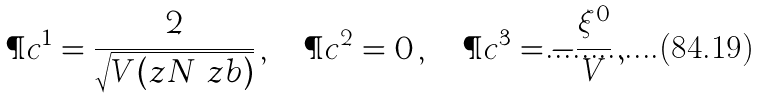Convert formula to latex. <formula><loc_0><loc_0><loc_500><loc_500>\P c ^ { 1 } = \frac { 2 } { \sqrt { V ( z N \ z b ) } } \, , \quad \P c ^ { 2 } = 0 \, , \quad \P c ^ { 3 } = - \frac { \xi ^ { 0 } } { V } \, ,</formula> 